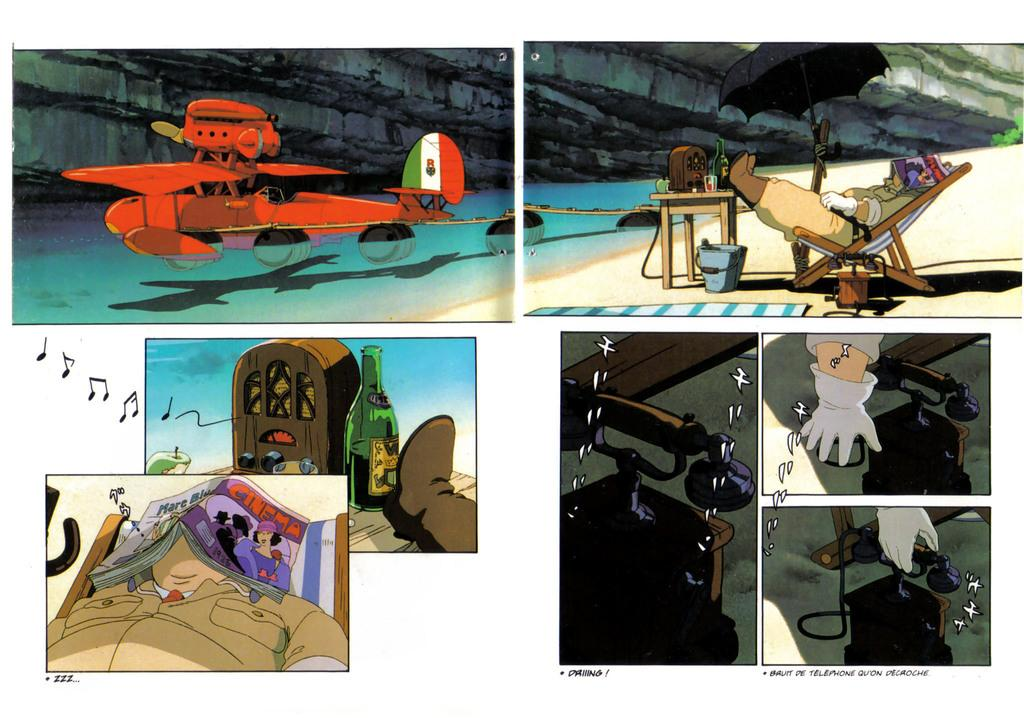<image>
Give a short and clear explanation of the subsequent image. Montage of animated photos with the caption "Bruit De Telephone Qu'On" on the bottom. 